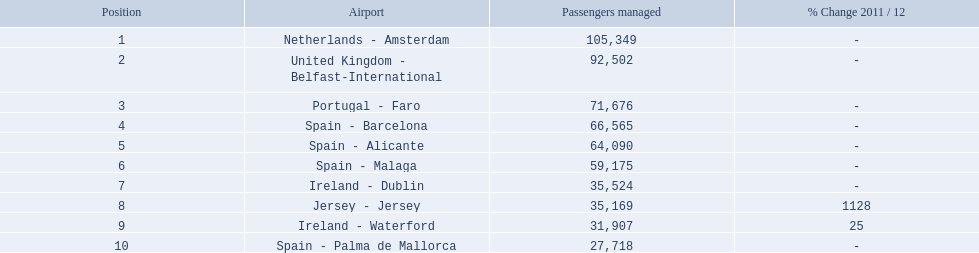How many passengers did the united kingdom handle? 92,502. Who handled more passengers than this? Netherlands - Amsterdam. What is the highest number of passengers handled? 105,349. What is the destination of the passengers leaving the area that handles 105,349 travellers? Netherlands - Amsterdam. 